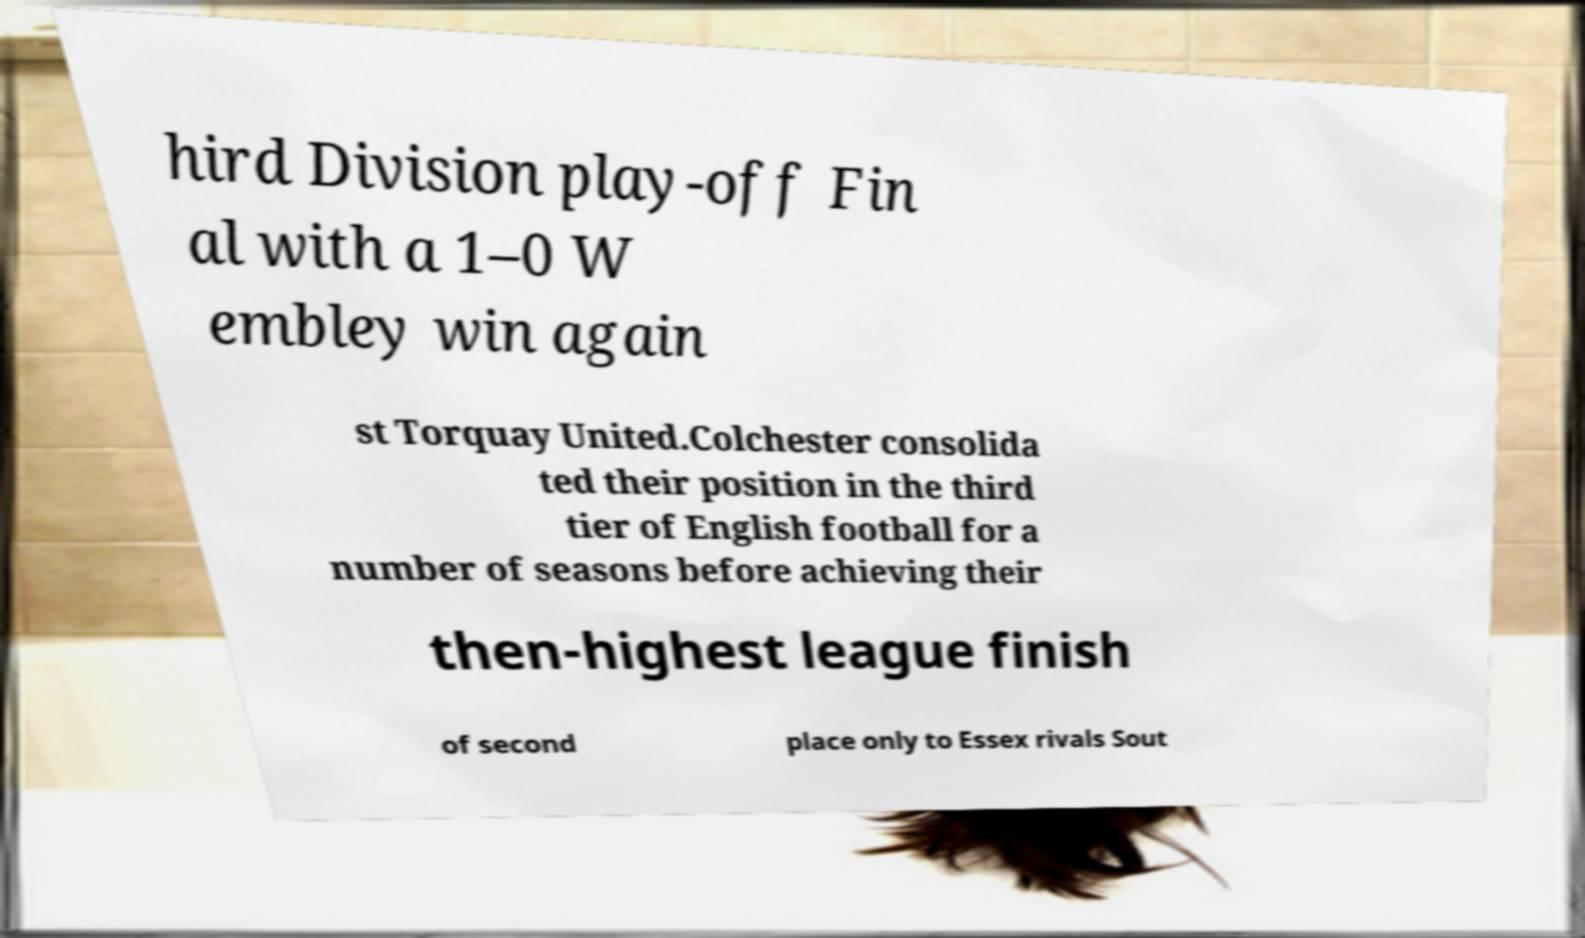Can you read and provide the text displayed in the image?This photo seems to have some interesting text. Can you extract and type it out for me? hird Division play-off Fin al with a 1–0 W embley win again st Torquay United.Colchester consolida ted their position in the third tier of English football for a number of seasons before achieving their then-highest league finish of second place only to Essex rivals Sout 